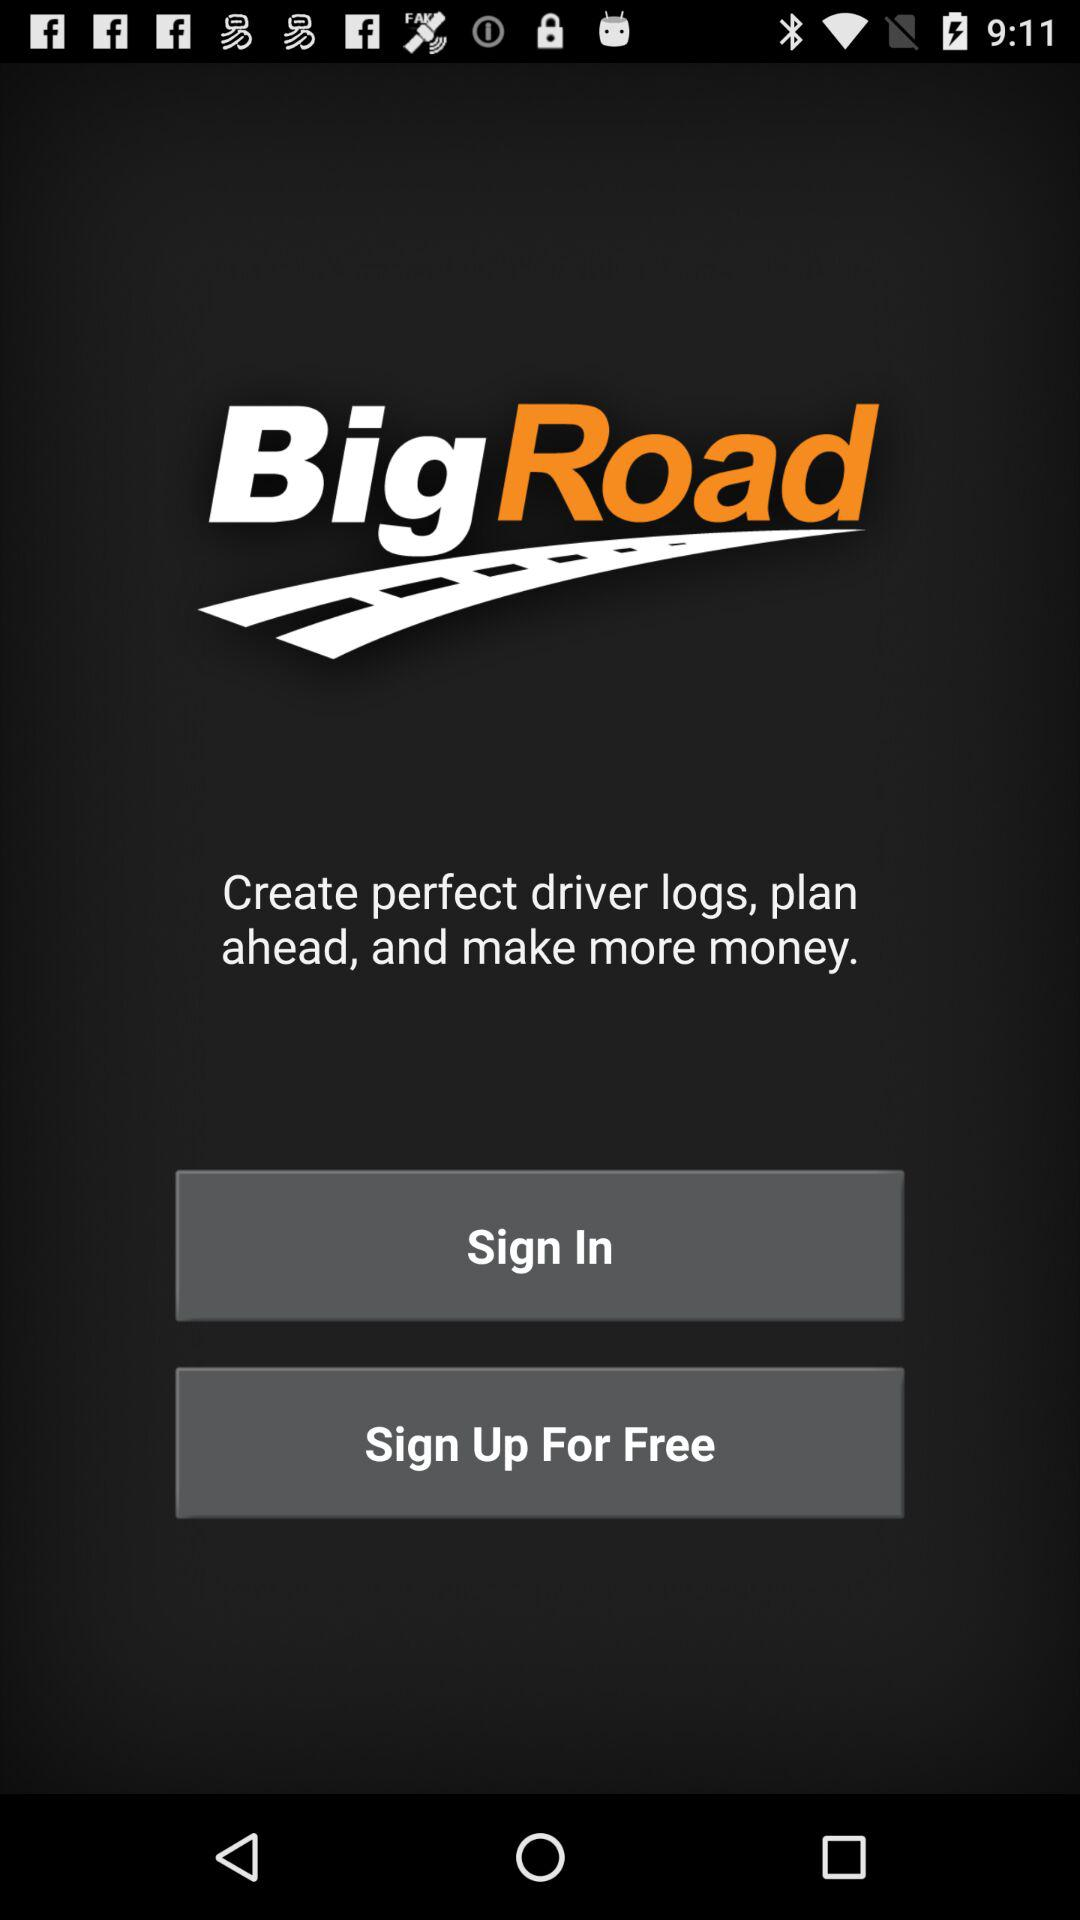What is the name of the application? The name of the application is "BigRoad". 